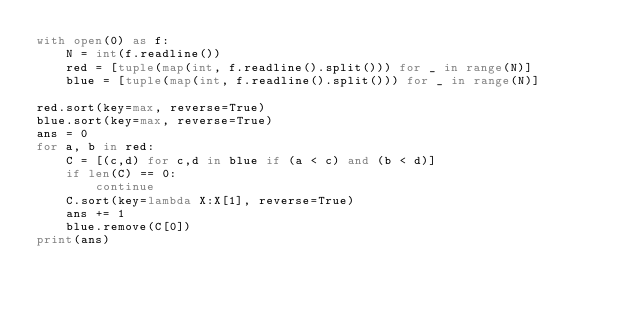Convert code to text. <code><loc_0><loc_0><loc_500><loc_500><_Python_>with open(0) as f:
    N = int(f.readline())
    red = [tuple(map(int, f.readline().split())) for _ in range(N)]
    blue = [tuple(map(int, f.readline().split())) for _ in range(N)]

red.sort(key=max, reverse=True)
blue.sort(key=max, reverse=True)
ans = 0
for a, b in red:
    C = [(c,d) for c,d in blue if (a < c) and (b < d)]
    if len(C) == 0:
        continue
    C.sort(key=lambda X:X[1], reverse=True)
    ans += 1
    blue.remove(C[0])
print(ans)</code> 